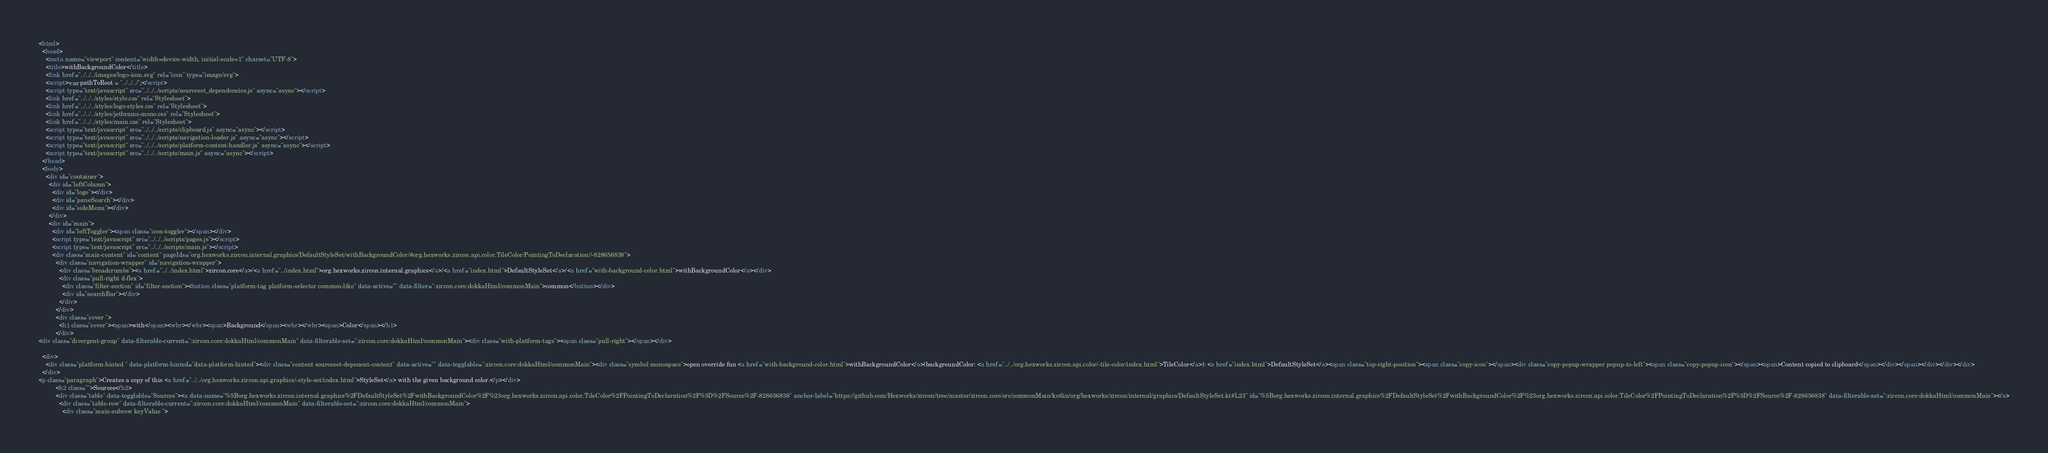<code> <loc_0><loc_0><loc_500><loc_500><_HTML_><html>
  <head>
    <meta name="viewport" content="width=device-width, initial-scale=1" charset="UTF-8">
    <title>withBackgroundColor</title>
    <link href="../../../images/logo-icon.svg" rel="icon" type="image/svg">
    <script>var pathToRoot = "../../../";</script>
    <script type="text/javascript" src="../../../scripts/sourceset_dependencies.js" async="async"></script>
    <link href="../../../styles/style.css" rel="Stylesheet">
    <link href="../../../styles/logo-styles.css" rel="Stylesheet">
    <link href="../../../styles/jetbrains-mono.css" rel="Stylesheet">
    <link href="../../../styles/main.css" rel="Stylesheet">
    <script type="text/javascript" src="../../../scripts/clipboard.js" async="async"></script>
    <script type="text/javascript" src="../../../scripts/navigation-loader.js" async="async"></script>
    <script type="text/javascript" src="../../../scripts/platform-content-handler.js" async="async"></script>
    <script type="text/javascript" src="../../../scripts/main.js" async="async"></script>
  </head>
  <body>
    <div id="container">
      <div id="leftColumn">
        <div id="logo"></div>
        <div id="paneSearch"></div>
        <div id="sideMenu"></div>
      </div>
      <div id="main">
        <div id="leftToggler"><span class="icon-toggler"></span></div>
        <script type="text/javascript" src="../../../scripts/pages.js"></script>
        <script type="text/javascript" src="../../../scripts/main.js"></script>
        <div class="main-content" id="content" pageIds="org.hexworks.zircon.internal.graphics/DefaultStyleSet/withBackgroundColor/#org.hexworks.zircon.api.color.TileColor/PointingToDeclaration//-828656838">
          <div class="navigation-wrapper" id="navigation-wrapper">
            <div class="breadcrumbs"><a href="../../index.html">zircon.core</a>/<a href="../index.html">org.hexworks.zircon.internal.graphics</a>/<a href="index.html">DefaultStyleSet</a>/<a href="with-background-color.html">withBackgroundColor</a></div>
            <div class="pull-right d-flex">
              <div class="filter-section" id="filter-section"><button class="platform-tag platform-selector common-like" data-active="" data-filter=":zircon.core:dokkaHtml/commonMain">common</button></div>
              <div id="searchBar"></div>
            </div>
          </div>
          <div class="cover ">
            <h1 class="cover"><span>with</span><wbr></wbr><span>Background</span><wbr></wbr><span>Color</span></h1>
          </div>
<div class="divergent-group" data-filterable-current=":zircon.core:dokkaHtml/commonMain" data-filterable-set=":zircon.core:dokkaHtml/commonMain"><div class="with-platform-tags"><span class="pull-right"></span></div>

  <div>
    <div class="platform-hinted " data-platform-hinted="data-platform-hinted"><div class="content sourceset-depenent-content" data-active="" data-togglable=":zircon.core:dokkaHtml/commonMain"><div class="symbol monospace">open override fun <a href="with-background-color.html">withBackgroundColor</a>(backgroundColor: <a href="../../org.hexworks.zircon.api.color/-tile-color/index.html">TileColor</a>): <a href="index.html">DefaultStyleSet</a><span class="top-right-position"><span class="copy-icon"></span><div class="copy-popup-wrapper popup-to-left"><span class="copy-popup-icon"></span><span>Content copied to clipboard</span></div></span></div></div></div>
  </div>
<p class="paragraph">Creates a copy of this <a href="../../org.hexworks.zircon.api.graphics/-style-set/index.html">StyleSet</a> with the given background color.</p></div>
          <h2 class="">Sources</h2>
          <div class="table" data-togglable="Sources"><a data-name="%5Borg.hexworks.zircon.internal.graphics%2FDefaultStyleSet%2FwithBackgroundColor%2F%23org.hexworks.zircon.api.color.TileColor%2FPointingToDeclaration%2F%5D%2FSource%2F-828656838" anchor-label="https://github.com/Hexworks/zircon/tree/master/zircon.core/src/commonMain/kotlin/org/hexworks/zircon/internal/graphics/DefaultStyleSet.kt#L23" id="%5Borg.hexworks.zircon.internal.graphics%2FDefaultStyleSet%2FwithBackgroundColor%2F%23org.hexworks.zircon.api.color.TileColor%2FPointingToDeclaration%2F%5D%2FSource%2F-828656838" data-filterable-set=":zircon.core:dokkaHtml/commonMain"></a>
            <div class="table-row" data-filterable-current=":zircon.core:dokkaHtml/commonMain" data-filterable-set=":zircon.core:dokkaHtml/commonMain">
              <div class="main-subrow keyValue "></code> 